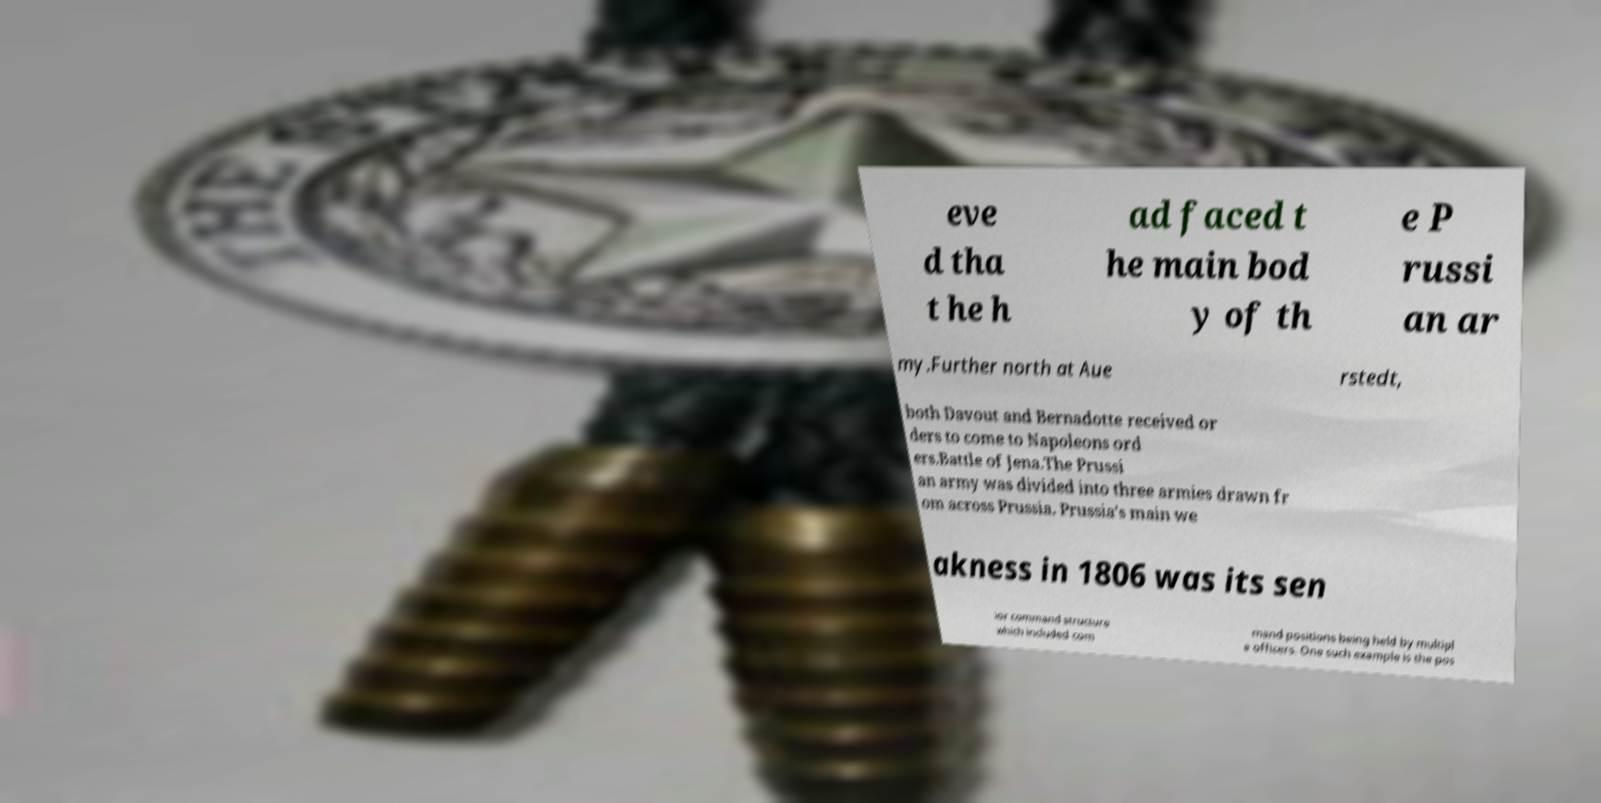Could you assist in decoding the text presented in this image and type it out clearly? eve d tha t he h ad faced t he main bod y of th e P russi an ar my.Further north at Aue rstedt, both Davout and Bernadotte received or ders to come to Napoleons ord ers.Battle of Jena.The Prussi an army was divided into three armies drawn fr om across Prussia. Prussia's main we akness in 1806 was its sen ior command structure which included com mand positions being held by multipl e officers. One such example is the pos 